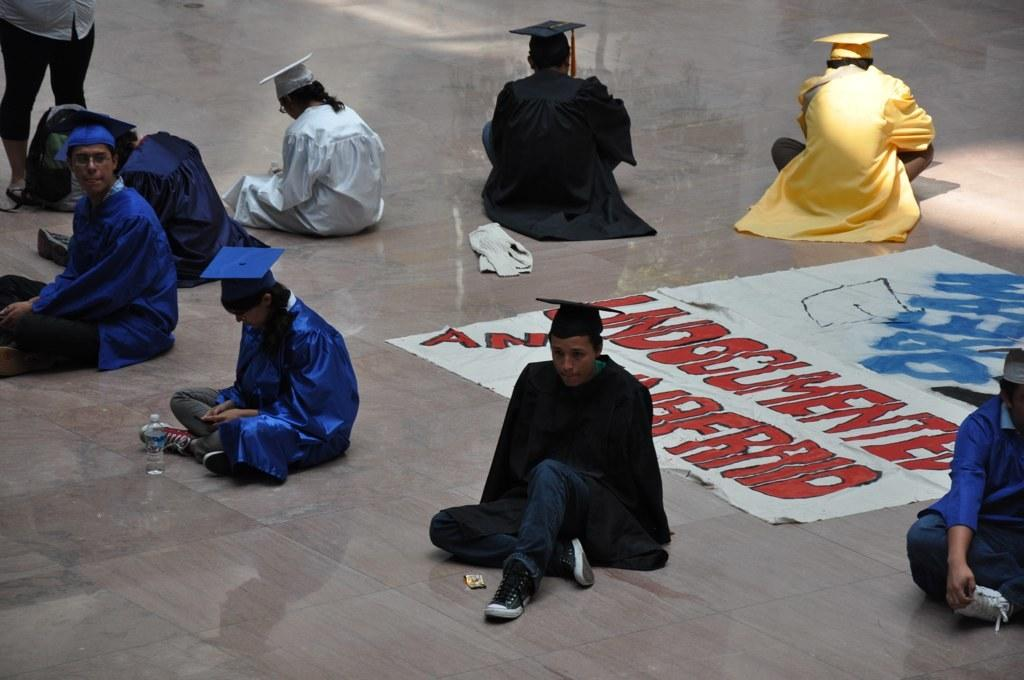How many people are in the image? There is a group of people in the image. What can be observed about the clothing of the people in the image? The people are wearing different colors. What position are the people in the image? The people are sitting on the ground. What is arranged on the floor in the image? There is a cloth arranged on the floor in the image. What type of pollution is visible in the image? There is no pollution visible in the image. What drug is being requested by the people in the image? There is no drug present or being requested in the image. 